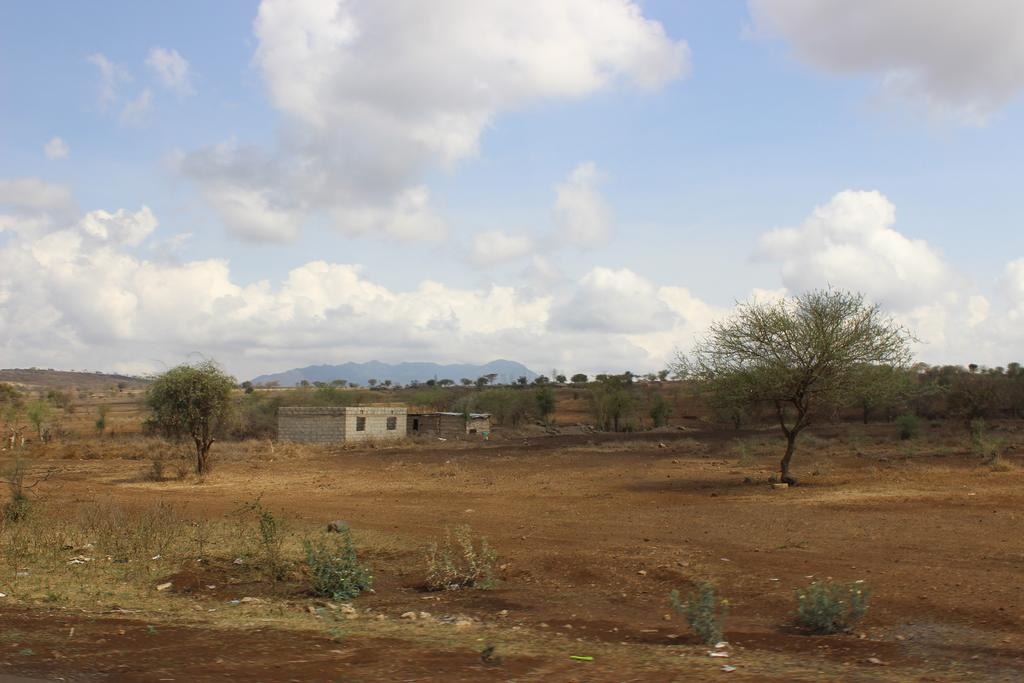What structures are located in the center of the image? There are two buildings with windows in the center of the image. What can be seen in the background of the image? There is a group of trees, plants, mountains, and a cloudy sky in the background. How many roses can be seen in the image? There are no roses present in the image. What type of care is being provided to the plants in the image? There is no indication of care being provided to the plants in the image. 